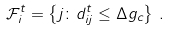<formula> <loc_0><loc_0><loc_500><loc_500>\mathcal { F } _ { i } ^ { t } = \left \{ j \colon d ^ { t } _ { i j } \leq \Delta g _ { c } \right \} \, .</formula> 